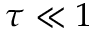<formula> <loc_0><loc_0><loc_500><loc_500>\tau \ll 1</formula> 